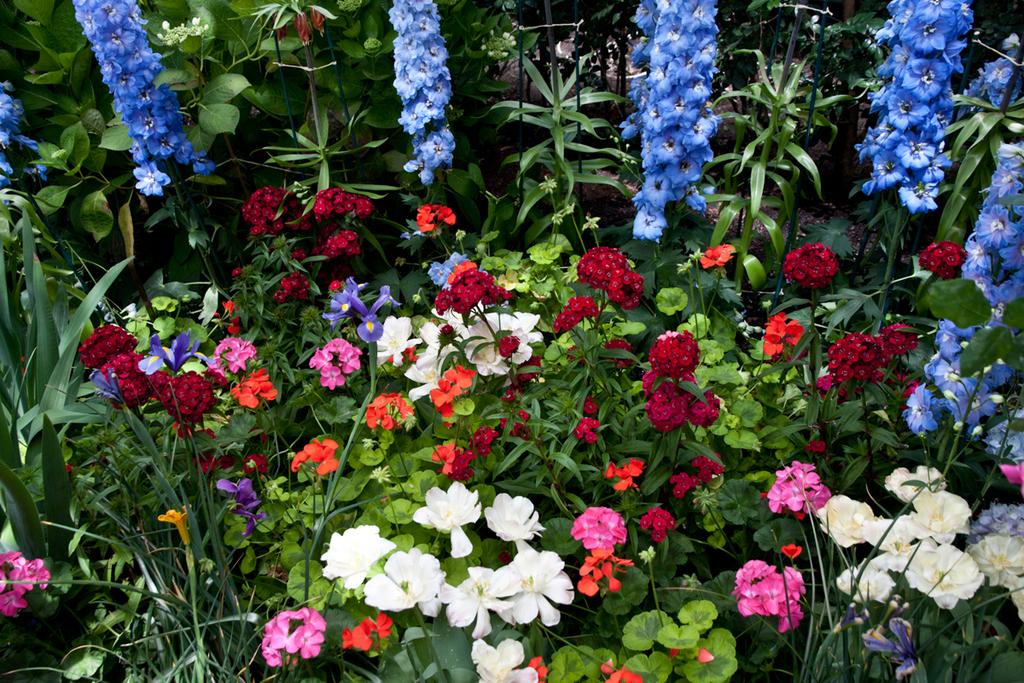What is located in the middle of the image? There are plants in the middle of the image. What types of flowers can be seen among the plants? There are different types of flowers in the middle of the image. What else can be seen among the plants? There are leaves in the middle of the image. What rule is being enforced by the hands in the image? There are no hands present in the image, and therefore no rule enforcement can be observed. 